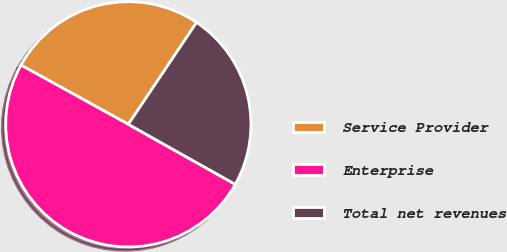Convert chart to OTSL. <chart><loc_0><loc_0><loc_500><loc_500><pie_chart><fcel>Service Provider<fcel>Enterprise<fcel>Total net revenues<nl><fcel>26.37%<fcel>49.88%<fcel>23.75%<nl></chart> 